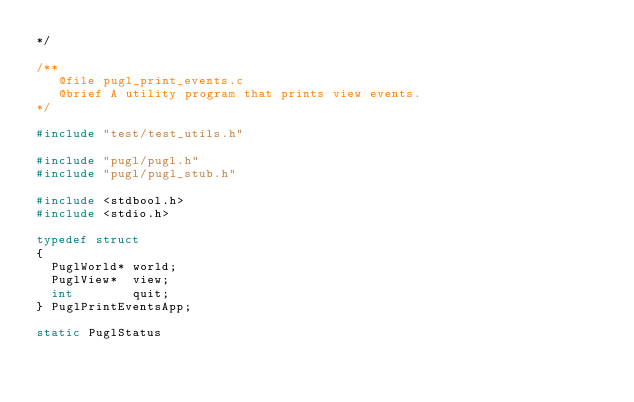Convert code to text. <code><loc_0><loc_0><loc_500><loc_500><_C_>*/

/**
   @file pugl_print_events.c
   @brief A utility program that prints view events.
*/

#include "test/test_utils.h"

#include "pugl/pugl.h"
#include "pugl/pugl_stub.h"

#include <stdbool.h>
#include <stdio.h>

typedef struct
{
	PuglWorld* world;
	PuglView*  view;
	int        quit;
} PuglPrintEventsApp;

static PuglStatus</code> 